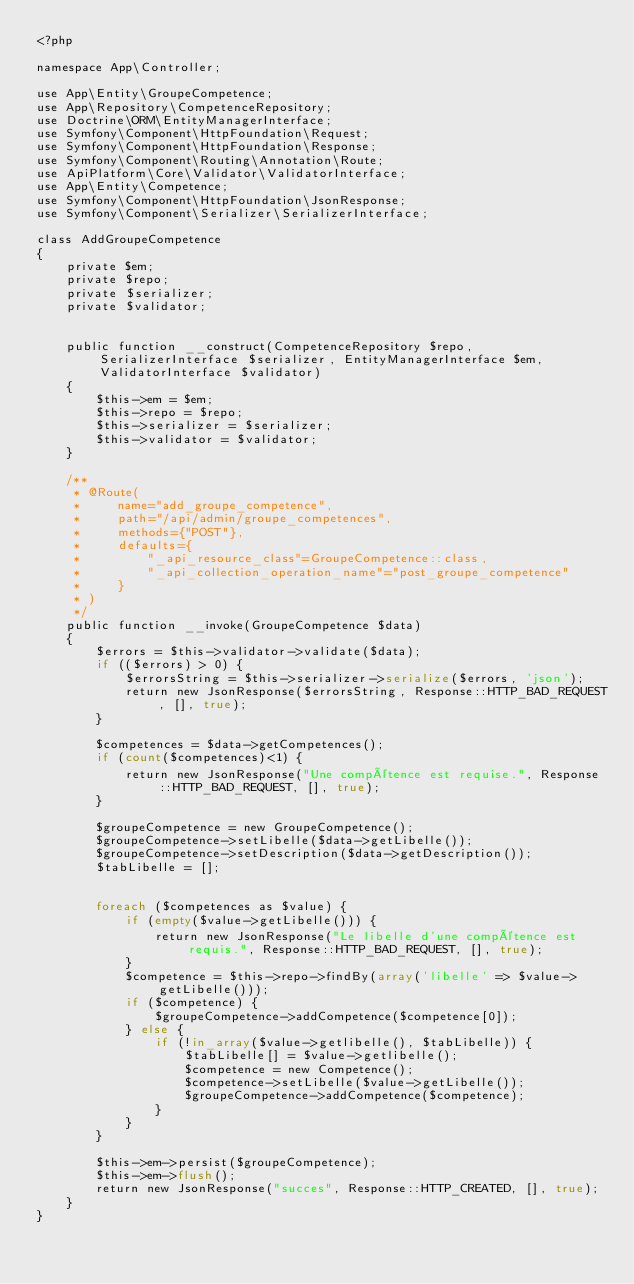Convert code to text. <code><loc_0><loc_0><loc_500><loc_500><_PHP_><?php

namespace App\Controller;

use App\Entity\GroupeCompetence;
use App\Repository\CompetenceRepository;
use Doctrine\ORM\EntityManagerInterface;
use Symfony\Component\HttpFoundation\Request;
use Symfony\Component\HttpFoundation\Response;
use Symfony\Component\Routing\Annotation\Route;
use ApiPlatform\Core\Validator\ValidatorInterface;
use App\Entity\Competence;
use Symfony\Component\HttpFoundation\JsonResponse;
use Symfony\Component\Serializer\SerializerInterface;

class AddGroupeCompetence
{
    private $em;
    private $repo;
    private $serializer;
    private $validator;


    public function __construct(CompetenceRepository $repo, SerializerInterface $serializer, EntityManagerInterface $em, ValidatorInterface $validator)
    {
        $this->em = $em;
        $this->repo = $repo;
        $this->serializer = $serializer;
        $this->validator = $validator;
    }

    /**
     * @Route(
     *     name="add_groupe_competence",
     *     path="/api/admin/groupe_competences",
     *     methods={"POST"},
     *     defaults={
     *         "_api_resource_class"=GroupeCompetence::class,
     *         "_api_collection_operation_name"="post_groupe_competence"
     *     }
     * )
     */
    public function __invoke(GroupeCompetence $data)
    {
        $errors = $this->validator->validate($data);
        if (($errors) > 0) {
            $errorsString = $this->serializer->serialize($errors, 'json');
            return new JsonResponse($errorsString, Response::HTTP_BAD_REQUEST, [], true);
        }

        $competences = $data->getCompetences();
        if (count($competences)<1) {
            return new JsonResponse("Une compétence est requise.", Response::HTTP_BAD_REQUEST, [], true);
        }

        $groupeCompetence = new GroupeCompetence();
        $groupeCompetence->setLibelle($data->getLibelle());
        $groupeCompetence->setDescription($data->getDescription());
        $tabLibelle = [];
        

        foreach ($competences as $value) {
            if (empty($value->getLibelle())) {
                return new JsonResponse("Le libelle d'une compétence est requis.", Response::HTTP_BAD_REQUEST, [], true);
            }
            $competence = $this->repo->findBy(array('libelle' => $value->getLibelle()));
            if ($competence) {
                $groupeCompetence->addCompetence($competence[0]);
            } else {
                if (!in_array($value->getlibelle(), $tabLibelle)) {
                    $tabLibelle[] = $value->getlibelle();
                    $competence = new Competence();
                    $competence->setLibelle($value->getLibelle());
                    $groupeCompetence->addCompetence($competence);
                }
            }
        }

        $this->em->persist($groupeCompetence);
        $this->em->flush();
        return new JsonResponse("succes", Response::HTTP_CREATED, [], true);
    }
}
</code> 